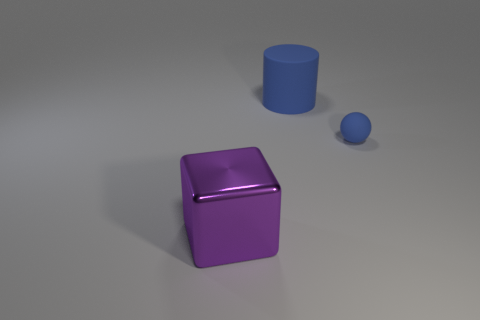Add 1 large things. How many objects exist? 4 Subtract 0 cyan cubes. How many objects are left? 3 Subtract all blocks. How many objects are left? 2 Subtract 1 cylinders. How many cylinders are left? 0 Subtract all small matte things. Subtract all big purple shiny objects. How many objects are left? 1 Add 1 big blue rubber objects. How many big blue rubber objects are left? 2 Add 2 blue rubber spheres. How many blue rubber spheres exist? 3 